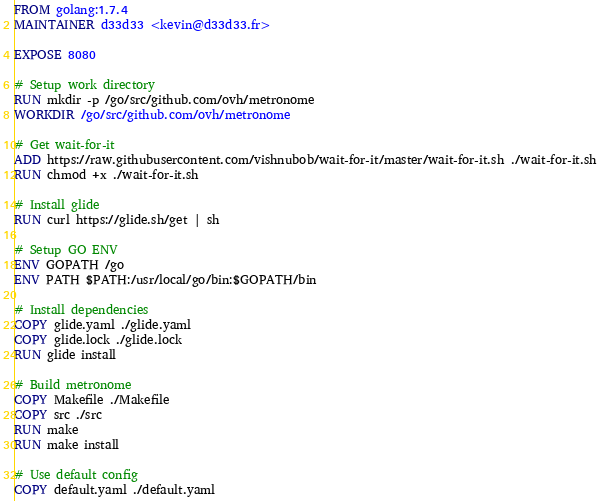Convert code to text. <code><loc_0><loc_0><loc_500><loc_500><_Dockerfile_>FROM golang:1.7.4
MAINTAINER d33d33 <kevin@d33d33.fr>

EXPOSE 8080

# Setup work directory
RUN mkdir -p /go/src/github.com/ovh/metronome
WORKDIR /go/src/github.com/ovh/metronome

# Get wait-for-it
ADD https://raw.githubusercontent.com/vishnubob/wait-for-it/master/wait-for-it.sh ./wait-for-it.sh
RUN chmod +x ./wait-for-it.sh

# Install glide
RUN curl https://glide.sh/get | sh

# Setup GO ENV
ENV GOPATH /go
ENV PATH $PATH:/usr/local/go/bin:$GOPATH/bin

# Install dependencies
COPY glide.yaml ./glide.yaml
COPY glide.lock ./glide.lock
RUN glide install

# Build metronome
COPY Makefile ./Makefile
COPY src ./src
RUN make
RUN make install

# Use default config
COPY default.yaml ./default.yaml
</code> 